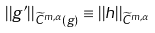<formula> <loc_0><loc_0><loc_500><loc_500>| | g ^ { \prime } | | _ { \widetilde { C } ^ { m , \alpha } ( g ) } \equiv | | h | | _ { \widetilde { C } ^ { m , \alpha } }</formula> 